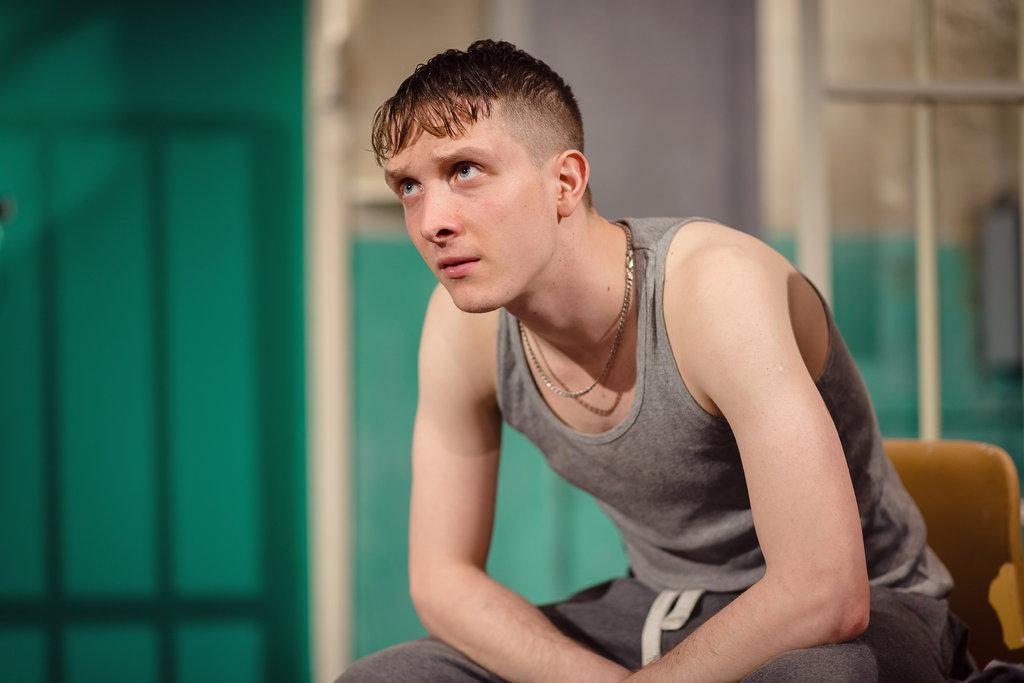Describe this image in one or two sentences. In this image we can see a man is sitting on a chair. He is wearing grey color dress and chain. In the background, we can see a wall. 